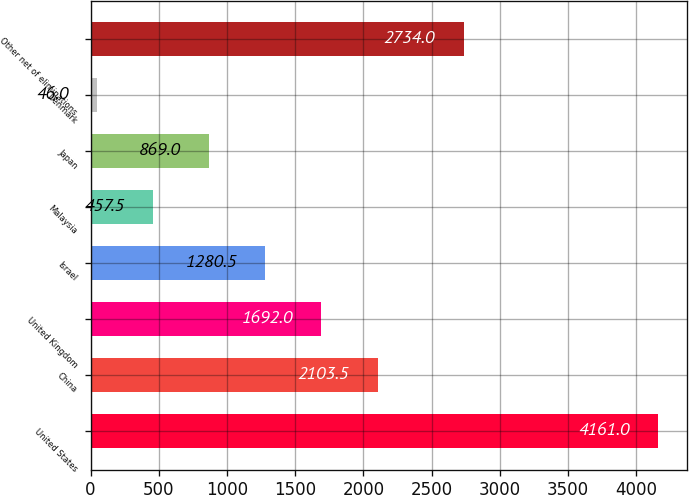<chart> <loc_0><loc_0><loc_500><loc_500><bar_chart><fcel>United States<fcel>China<fcel>United Kingdom<fcel>Israel<fcel>Malaysia<fcel>Japan<fcel>Denmark<fcel>Other net of eliminations<nl><fcel>4161<fcel>2103.5<fcel>1692<fcel>1280.5<fcel>457.5<fcel>869<fcel>46<fcel>2734<nl></chart> 